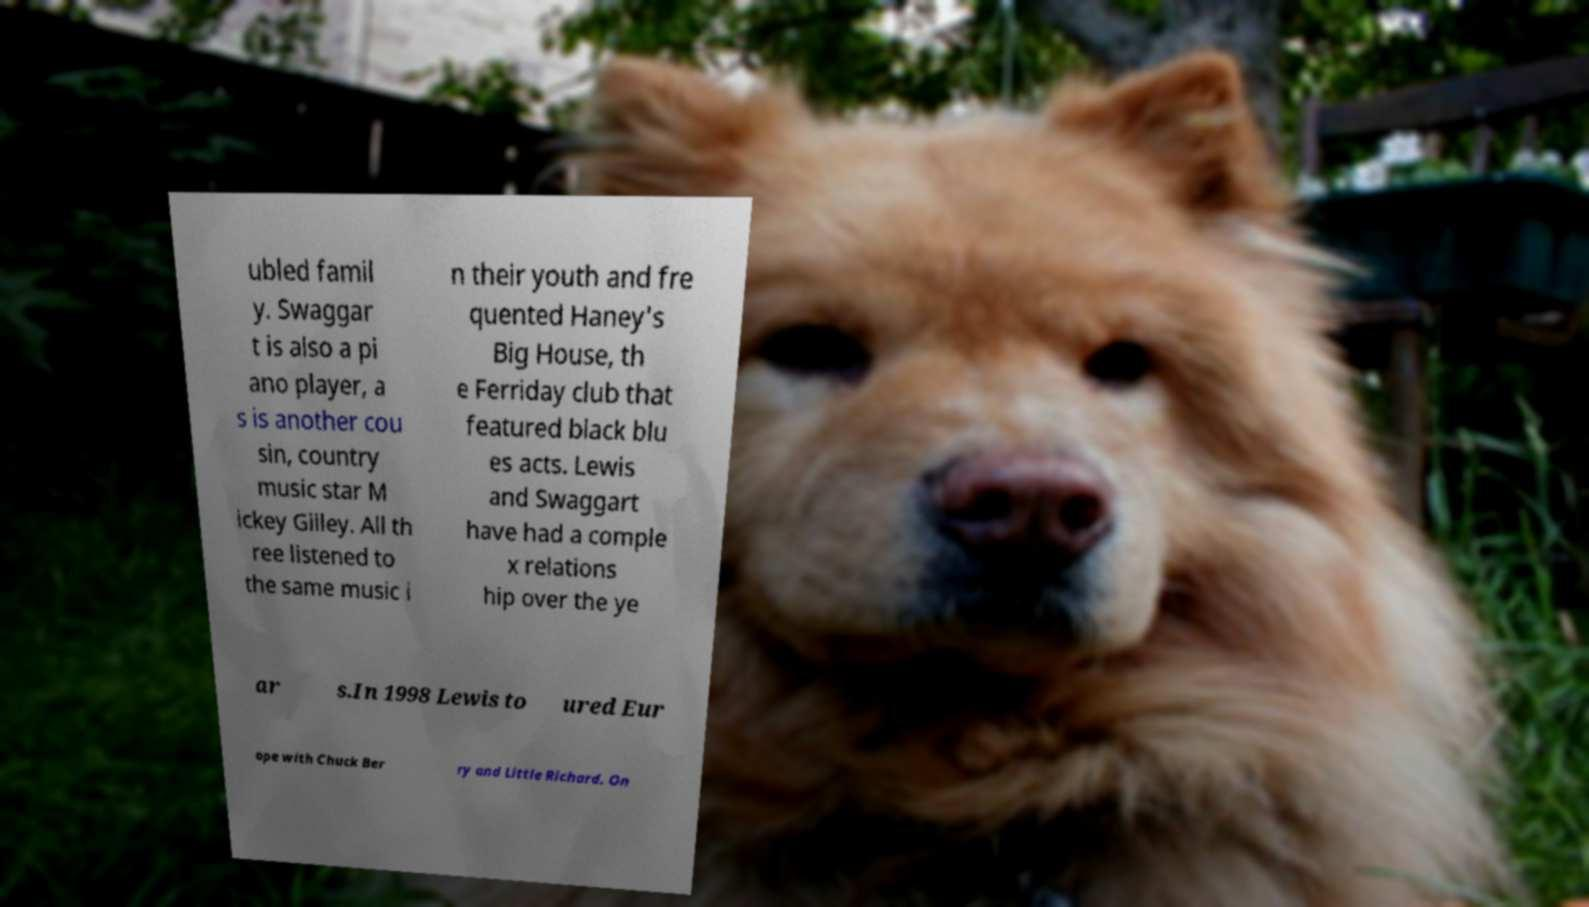Can you accurately transcribe the text from the provided image for me? ubled famil y. Swaggar t is also a pi ano player, a s is another cou sin, country music star M ickey Gilley. All th ree listened to the same music i n their youth and fre quented Haney's Big House, th e Ferriday club that featured black blu es acts. Lewis and Swaggart have had a comple x relations hip over the ye ar s.In 1998 Lewis to ured Eur ope with Chuck Ber ry and Little Richard. On 